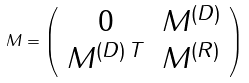<formula> <loc_0><loc_0><loc_500><loc_500>M = \left ( \begin{array} { c c } { 0 } & { { M ^ { ( D ) } } } \\ { { M ^ { ( D ) \, T } } } & { { M ^ { ( R ) } } } \end{array} \right )</formula> 